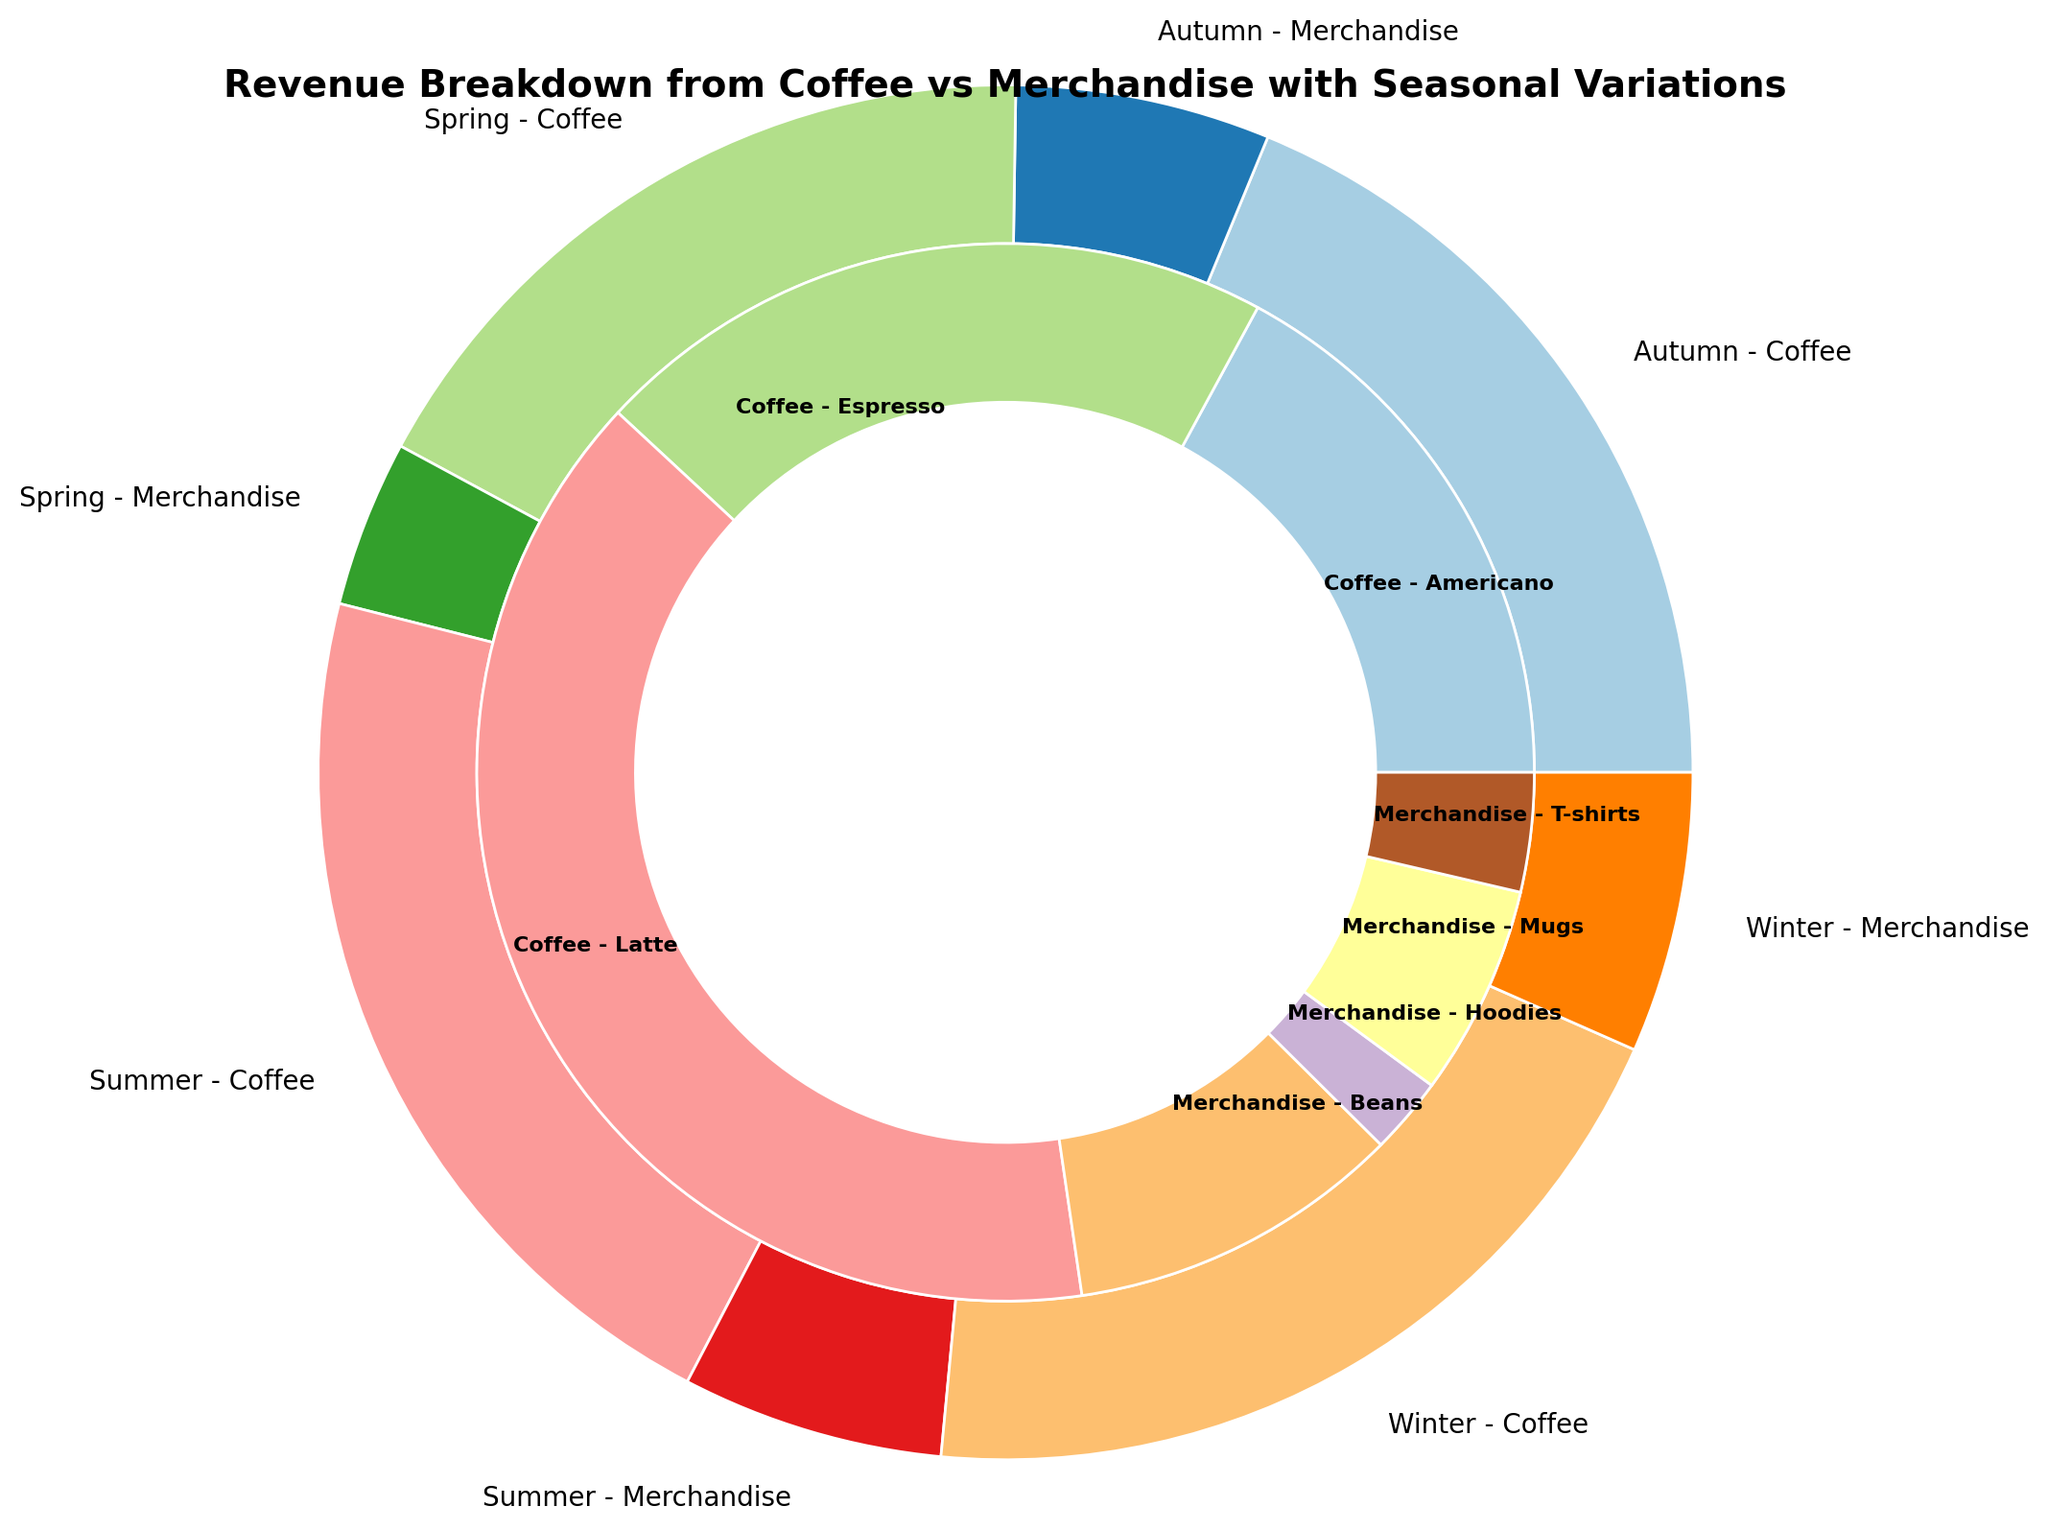Which season had the highest revenue from coffee? By looking at the figures for each season, sum up the revenue from all coffee items for each season and compare them. The highest revenue from coffee appears in Summer: (Latte: 20000 + Espresso: 10000 + Americano: 8000) = 38000
Answer: Summer What is the total revenue generated from merchandise in Winter? To find the total revenue from merchandise in Winter, sum up the revenue for all merchandise items in Winter: (Mugs: 2800 + Beans: 4800 + Hoodies: 4200) = 11800
Answer: 11800 Which item made the least revenue in Spring across coffee and merchandise? By looking at the revenue values for each item in Spring, identify the smallest number. The item with the least revenue is Mugs, with 3000
Answer: Mugs Compare the revenue from T-shirts in Autumn and Summer. Which season had higher T-shirt sales? Compare the revenue for T-shirts in Autumn and Summer: Autumn (3000) and Summer (3500). Since 3500 > 3000, Summer had higher T-shirt sales
Answer: Summer What is the total revenue for Latte across all seasons? Sum up the revenue for Latte in all seasons: Spring (15000) + Summer (20000) + Autumn (17000) + Winter (18000) = 70000
Answer: 70000 Which season generated more revenue from Espresso, Spring or Winter? Compare the revenue from Espresso in Spring (9000) and Winter (9500). Since 9500 > 9000, Winter generated more revenue from Espresso
Answer: Winter What is the average revenue from Beans across all seasons? Calculate the average revenue for Beans by summing up the revenue from each season and dividing by the number of seasons: (Spring: 4000 + Summer: 5000 + Autumn: 4500 + Winter: 4800) / 4 = 4600
Answer: 4600 Which category, Coffee or Merchandise, had more revenue in Autumn? Compare the total revenue from Coffee (Latte: 17000 + Espresso: 9000 + Americano: 7500 = 33500) and Merchandise (Mugs: 3200 + Beans: 4500 + T-shirts: 3000 = 10700) in Autumn. Since 33500 > 10700, Coffee had more revenue
Answer: Coffee How does the revenue from merchandise in Winter compare to that in Spring? Compare the total merchandise revenue in Winter (11800) and Spring (7000). Since 11800 > 7000, Winter had more merchandise revenue
Answer: Winter What is the total revenue generated in Summer? Sum up all revenue categories in Summer: Coffee (Latte: 20000 + Espresso: 10000 + Americano: 8000 = 38000) and Merchandise (Mugs: 2500 + Beans: 5000 + T-shirts: 3500 = 11000). Total Summer revenue: 38000 + 11000 = 49000
Answer: 49000 